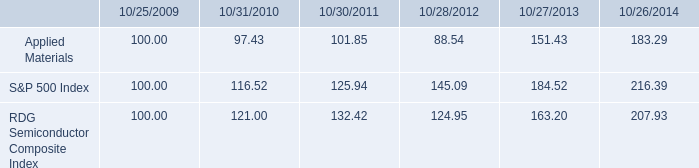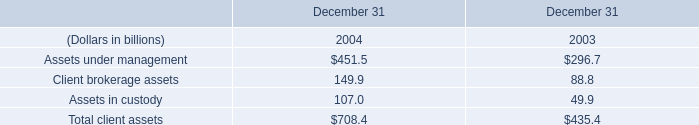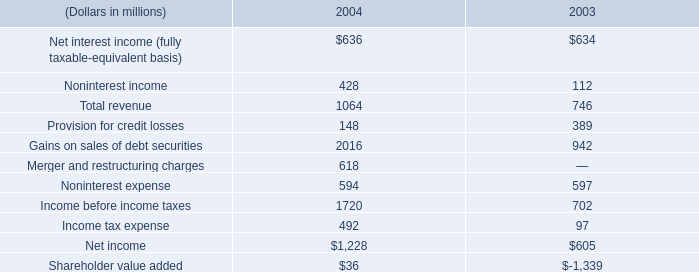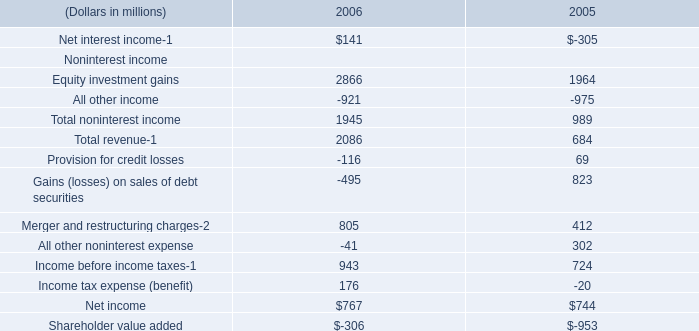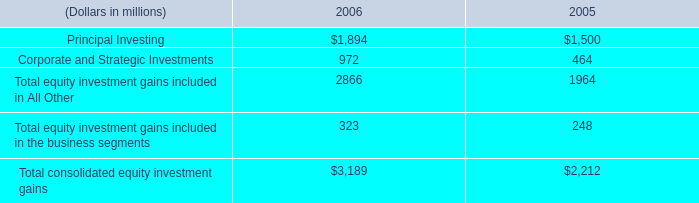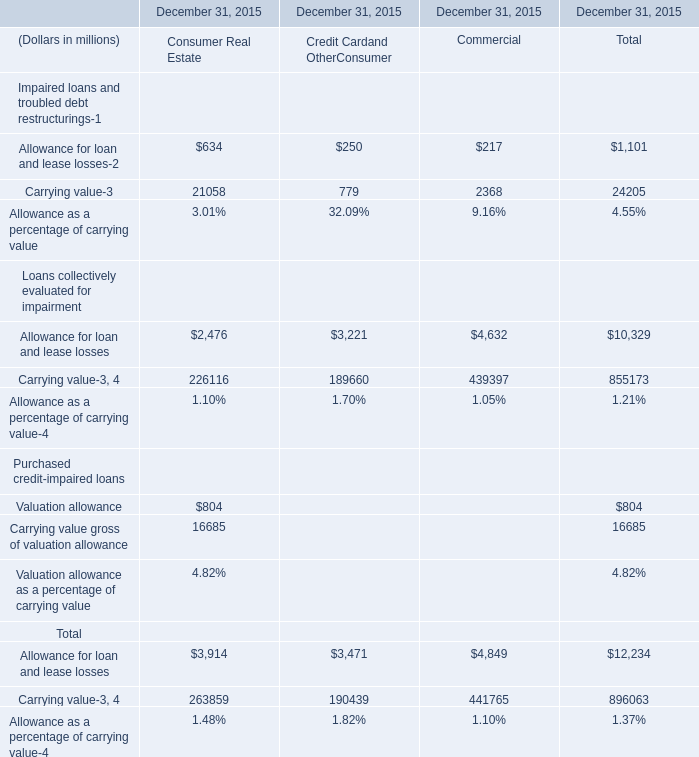What's the average of Equity investment gains Noninterest income of 2006, and Income before income taxes of 2004 ? 
Computations: ((2866.0 + 1720.0) / 2)
Answer: 2293.0. 